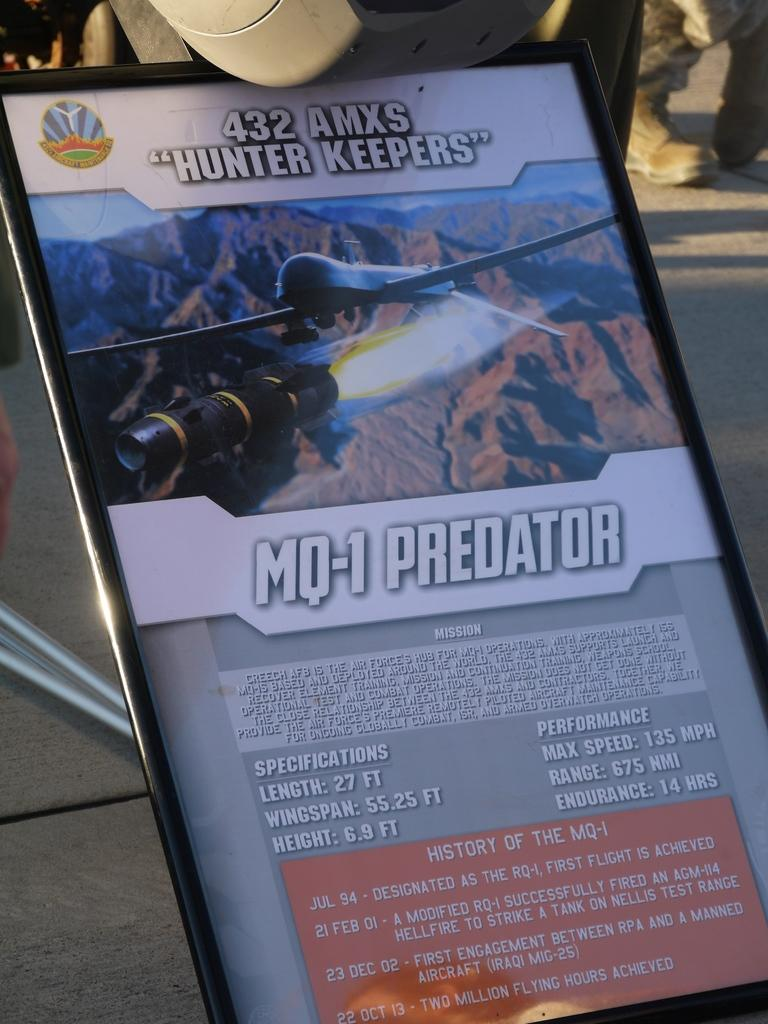<image>
Provide a brief description of the given image. a flyer that says 'mo-1 predator' on it 